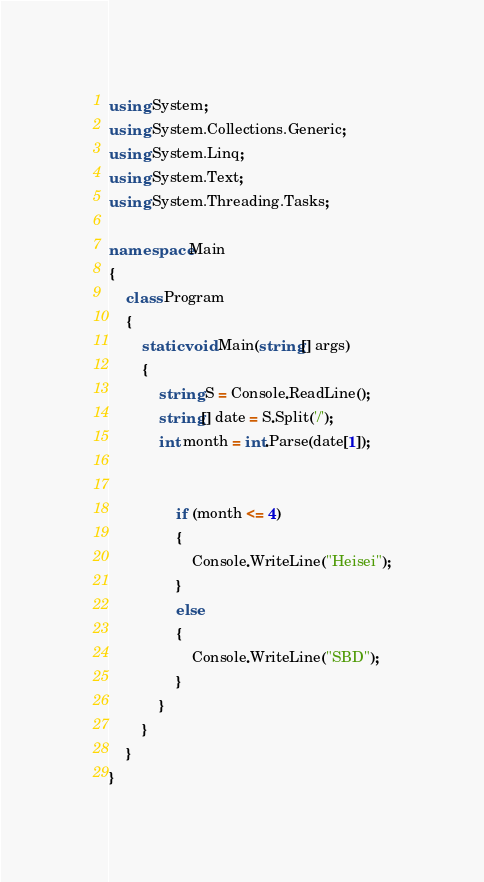Convert code to text. <code><loc_0><loc_0><loc_500><loc_500><_C#_>using System;
using System.Collections.Generic;
using System.Linq;
using System.Text;
using System.Threading.Tasks;

namespace Main
{
    class Program
    {
        static void Main(string[] args)
        {
            string S = Console.ReadLine();
            string[] date = S.Split('/');
            int month = int.Parse(date[1]);


                if (month <= 4)
                {
                    Console.WriteLine("Heisei");
                }
                else
                {
                    Console.WriteLine("SBD");
                }
            }
        }
    }
}
</code> 